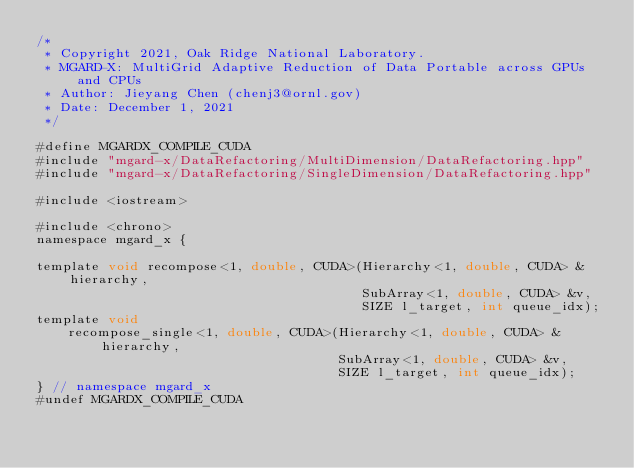<code> <loc_0><loc_0><loc_500><loc_500><_Cuda_>/*
 * Copyright 2021, Oak Ridge National Laboratory.
 * MGARD-X: MultiGrid Adaptive Reduction of Data Portable across GPUs and CPUs
 * Author: Jieyang Chen (chenj3@ornl.gov)
 * Date: December 1, 2021
 */

#define MGARDX_COMPILE_CUDA
#include "mgard-x/DataRefactoring/MultiDimension/DataRefactoring.hpp"
#include "mgard-x/DataRefactoring/SingleDimension/DataRefactoring.hpp"

#include <iostream>

#include <chrono>
namespace mgard_x {

template void recompose<1, double, CUDA>(Hierarchy<1, double, CUDA> &hierarchy,
                                         SubArray<1, double, CUDA> &v,
                                         SIZE l_target, int queue_idx);
template void
    recompose_single<1, double, CUDA>(Hierarchy<1, double, CUDA> &hierarchy,
                                      SubArray<1, double, CUDA> &v,
                                      SIZE l_target, int queue_idx);
} // namespace mgard_x
#undef MGARDX_COMPILE_CUDA
</code> 